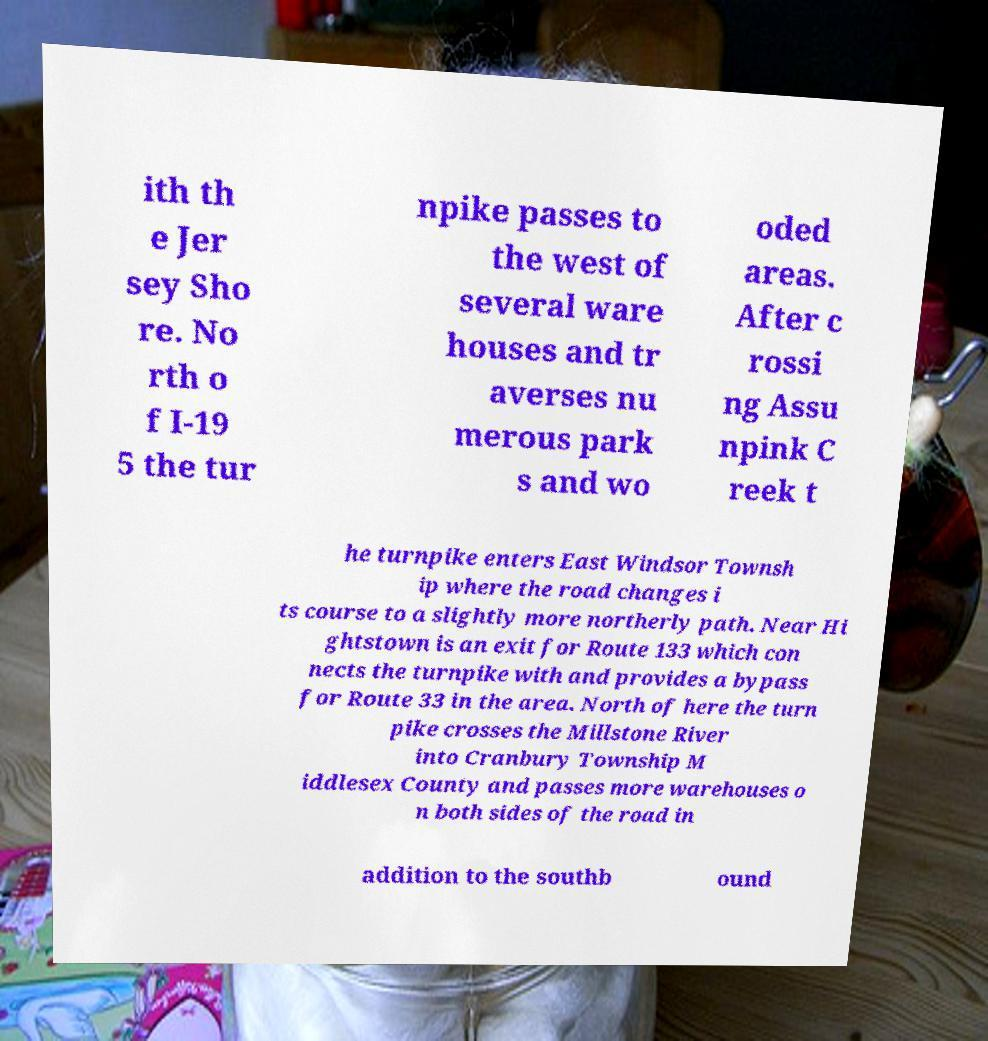Please read and relay the text visible in this image. What does it say? ith th e Jer sey Sho re. No rth o f I-19 5 the tur npike passes to the west of several ware houses and tr averses nu merous park s and wo oded areas. After c rossi ng Assu npink C reek t he turnpike enters East Windsor Townsh ip where the road changes i ts course to a slightly more northerly path. Near Hi ghtstown is an exit for Route 133 which con nects the turnpike with and provides a bypass for Route 33 in the area. North of here the turn pike crosses the Millstone River into Cranbury Township M iddlesex County and passes more warehouses o n both sides of the road in addition to the southb ound 